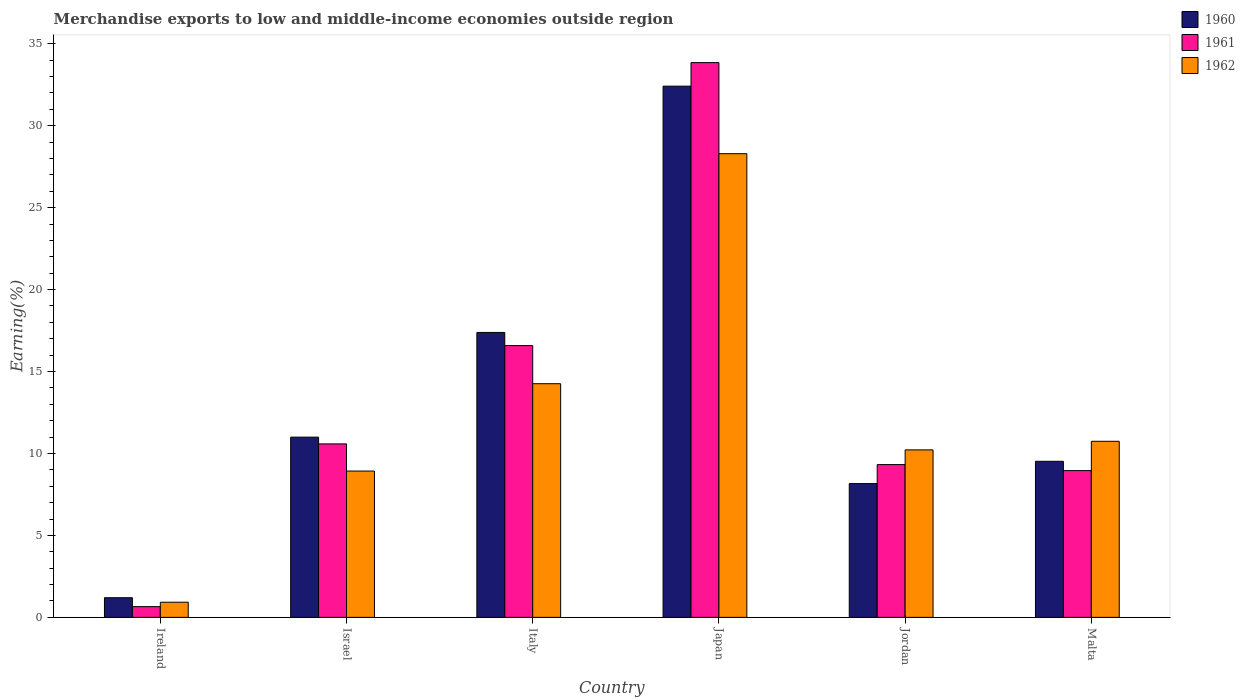Are the number of bars per tick equal to the number of legend labels?
Ensure brevity in your answer.  Yes. How many bars are there on the 6th tick from the right?
Offer a very short reply. 3. What is the label of the 3rd group of bars from the left?
Your answer should be compact. Italy. In how many cases, is the number of bars for a given country not equal to the number of legend labels?
Your answer should be compact. 0. What is the percentage of amount earned from merchandise exports in 1960 in Israel?
Make the answer very short. 11. Across all countries, what is the maximum percentage of amount earned from merchandise exports in 1960?
Offer a terse response. 32.41. Across all countries, what is the minimum percentage of amount earned from merchandise exports in 1962?
Offer a very short reply. 0.92. In which country was the percentage of amount earned from merchandise exports in 1960 maximum?
Keep it short and to the point. Japan. In which country was the percentage of amount earned from merchandise exports in 1962 minimum?
Offer a terse response. Ireland. What is the total percentage of amount earned from merchandise exports in 1962 in the graph?
Offer a very short reply. 73.37. What is the difference between the percentage of amount earned from merchandise exports in 1962 in Italy and that in Jordan?
Ensure brevity in your answer.  4.04. What is the difference between the percentage of amount earned from merchandise exports in 1962 in Israel and the percentage of amount earned from merchandise exports in 1961 in Italy?
Offer a very short reply. -7.66. What is the average percentage of amount earned from merchandise exports in 1961 per country?
Provide a succinct answer. 13.33. What is the difference between the percentage of amount earned from merchandise exports of/in 1961 and percentage of amount earned from merchandise exports of/in 1962 in Jordan?
Make the answer very short. -0.9. In how many countries, is the percentage of amount earned from merchandise exports in 1961 greater than 2 %?
Your response must be concise. 5. What is the ratio of the percentage of amount earned from merchandise exports in 1962 in Ireland to that in Malta?
Ensure brevity in your answer.  0.09. Is the percentage of amount earned from merchandise exports in 1961 in Ireland less than that in Japan?
Your answer should be compact. Yes. Is the difference between the percentage of amount earned from merchandise exports in 1961 in Jordan and Malta greater than the difference between the percentage of amount earned from merchandise exports in 1962 in Jordan and Malta?
Give a very brief answer. Yes. What is the difference between the highest and the second highest percentage of amount earned from merchandise exports in 1961?
Your answer should be very brief. -17.27. What is the difference between the highest and the lowest percentage of amount earned from merchandise exports in 1960?
Ensure brevity in your answer.  31.21. In how many countries, is the percentage of amount earned from merchandise exports in 1961 greater than the average percentage of amount earned from merchandise exports in 1961 taken over all countries?
Ensure brevity in your answer.  2. Is the sum of the percentage of amount earned from merchandise exports in 1961 in Israel and Malta greater than the maximum percentage of amount earned from merchandise exports in 1962 across all countries?
Provide a succinct answer. No. What does the 2nd bar from the left in Israel represents?
Your answer should be compact. 1961. How many countries are there in the graph?
Make the answer very short. 6. What is the difference between two consecutive major ticks on the Y-axis?
Offer a very short reply. 5. What is the title of the graph?
Your answer should be very brief. Merchandise exports to low and middle-income economies outside region. Does "1990" appear as one of the legend labels in the graph?
Offer a very short reply. No. What is the label or title of the Y-axis?
Offer a terse response. Earning(%). What is the Earning(%) of 1960 in Ireland?
Your answer should be very brief. 1.2. What is the Earning(%) of 1961 in Ireland?
Keep it short and to the point. 0.65. What is the Earning(%) of 1962 in Ireland?
Your answer should be very brief. 0.92. What is the Earning(%) in 1960 in Israel?
Make the answer very short. 11. What is the Earning(%) in 1961 in Israel?
Your answer should be compact. 10.58. What is the Earning(%) of 1962 in Israel?
Offer a very short reply. 8.93. What is the Earning(%) of 1960 in Italy?
Provide a short and direct response. 17.38. What is the Earning(%) of 1961 in Italy?
Offer a very short reply. 16.58. What is the Earning(%) in 1962 in Italy?
Ensure brevity in your answer.  14.26. What is the Earning(%) in 1960 in Japan?
Your answer should be compact. 32.41. What is the Earning(%) in 1961 in Japan?
Make the answer very short. 33.85. What is the Earning(%) of 1962 in Japan?
Provide a succinct answer. 28.29. What is the Earning(%) of 1960 in Jordan?
Keep it short and to the point. 8.16. What is the Earning(%) in 1961 in Jordan?
Your answer should be very brief. 9.32. What is the Earning(%) in 1962 in Jordan?
Offer a terse response. 10.22. What is the Earning(%) of 1960 in Malta?
Offer a terse response. 9.52. What is the Earning(%) of 1961 in Malta?
Your response must be concise. 8.96. What is the Earning(%) of 1962 in Malta?
Offer a very short reply. 10.74. Across all countries, what is the maximum Earning(%) of 1960?
Your answer should be very brief. 32.41. Across all countries, what is the maximum Earning(%) in 1961?
Provide a succinct answer. 33.85. Across all countries, what is the maximum Earning(%) in 1962?
Offer a very short reply. 28.29. Across all countries, what is the minimum Earning(%) of 1960?
Your response must be concise. 1.2. Across all countries, what is the minimum Earning(%) in 1961?
Provide a short and direct response. 0.65. Across all countries, what is the minimum Earning(%) in 1962?
Your answer should be compact. 0.92. What is the total Earning(%) of 1960 in the graph?
Provide a short and direct response. 79.68. What is the total Earning(%) in 1961 in the graph?
Provide a succinct answer. 79.95. What is the total Earning(%) of 1962 in the graph?
Give a very brief answer. 73.37. What is the difference between the Earning(%) in 1960 in Ireland and that in Israel?
Offer a very short reply. -9.8. What is the difference between the Earning(%) of 1961 in Ireland and that in Israel?
Provide a short and direct response. -9.93. What is the difference between the Earning(%) in 1962 in Ireland and that in Israel?
Provide a succinct answer. -8. What is the difference between the Earning(%) of 1960 in Ireland and that in Italy?
Your answer should be compact. -16.19. What is the difference between the Earning(%) of 1961 in Ireland and that in Italy?
Your response must be concise. -15.93. What is the difference between the Earning(%) of 1962 in Ireland and that in Italy?
Keep it short and to the point. -13.33. What is the difference between the Earning(%) of 1960 in Ireland and that in Japan?
Offer a very short reply. -31.21. What is the difference between the Earning(%) in 1961 in Ireland and that in Japan?
Your answer should be very brief. -33.2. What is the difference between the Earning(%) in 1962 in Ireland and that in Japan?
Provide a short and direct response. -27.37. What is the difference between the Earning(%) of 1960 in Ireland and that in Jordan?
Provide a short and direct response. -6.96. What is the difference between the Earning(%) in 1961 in Ireland and that in Jordan?
Provide a short and direct response. -8.67. What is the difference between the Earning(%) of 1962 in Ireland and that in Jordan?
Offer a terse response. -9.29. What is the difference between the Earning(%) of 1960 in Ireland and that in Malta?
Give a very brief answer. -8.32. What is the difference between the Earning(%) of 1961 in Ireland and that in Malta?
Offer a very short reply. -8.3. What is the difference between the Earning(%) of 1962 in Ireland and that in Malta?
Keep it short and to the point. -9.82. What is the difference between the Earning(%) of 1960 in Israel and that in Italy?
Provide a succinct answer. -6.39. What is the difference between the Earning(%) in 1961 in Israel and that in Italy?
Keep it short and to the point. -6. What is the difference between the Earning(%) of 1962 in Israel and that in Italy?
Offer a very short reply. -5.33. What is the difference between the Earning(%) of 1960 in Israel and that in Japan?
Provide a succinct answer. -21.42. What is the difference between the Earning(%) in 1961 in Israel and that in Japan?
Give a very brief answer. -23.27. What is the difference between the Earning(%) in 1962 in Israel and that in Japan?
Make the answer very short. -19.37. What is the difference between the Earning(%) of 1960 in Israel and that in Jordan?
Your answer should be compact. 2.83. What is the difference between the Earning(%) of 1961 in Israel and that in Jordan?
Offer a terse response. 1.26. What is the difference between the Earning(%) of 1962 in Israel and that in Jordan?
Give a very brief answer. -1.29. What is the difference between the Earning(%) in 1960 in Israel and that in Malta?
Offer a terse response. 1.47. What is the difference between the Earning(%) of 1961 in Israel and that in Malta?
Your answer should be compact. 1.63. What is the difference between the Earning(%) in 1962 in Israel and that in Malta?
Offer a very short reply. -1.82. What is the difference between the Earning(%) of 1960 in Italy and that in Japan?
Your response must be concise. -15.03. What is the difference between the Earning(%) in 1961 in Italy and that in Japan?
Your answer should be compact. -17.27. What is the difference between the Earning(%) in 1962 in Italy and that in Japan?
Your answer should be compact. -14.04. What is the difference between the Earning(%) of 1960 in Italy and that in Jordan?
Keep it short and to the point. 9.22. What is the difference between the Earning(%) in 1961 in Italy and that in Jordan?
Provide a succinct answer. 7.26. What is the difference between the Earning(%) of 1962 in Italy and that in Jordan?
Offer a terse response. 4.04. What is the difference between the Earning(%) of 1960 in Italy and that in Malta?
Your response must be concise. 7.86. What is the difference between the Earning(%) in 1961 in Italy and that in Malta?
Ensure brevity in your answer.  7.63. What is the difference between the Earning(%) in 1962 in Italy and that in Malta?
Make the answer very short. 3.51. What is the difference between the Earning(%) in 1960 in Japan and that in Jordan?
Provide a succinct answer. 24.25. What is the difference between the Earning(%) of 1961 in Japan and that in Jordan?
Give a very brief answer. 24.53. What is the difference between the Earning(%) in 1962 in Japan and that in Jordan?
Keep it short and to the point. 18.07. What is the difference between the Earning(%) in 1960 in Japan and that in Malta?
Provide a succinct answer. 22.89. What is the difference between the Earning(%) of 1961 in Japan and that in Malta?
Your answer should be very brief. 24.9. What is the difference between the Earning(%) of 1962 in Japan and that in Malta?
Your response must be concise. 17.55. What is the difference between the Earning(%) of 1960 in Jordan and that in Malta?
Your response must be concise. -1.36. What is the difference between the Earning(%) in 1961 in Jordan and that in Malta?
Offer a very short reply. 0.37. What is the difference between the Earning(%) of 1962 in Jordan and that in Malta?
Provide a succinct answer. -0.52. What is the difference between the Earning(%) in 1960 in Ireland and the Earning(%) in 1961 in Israel?
Make the answer very short. -9.39. What is the difference between the Earning(%) of 1960 in Ireland and the Earning(%) of 1962 in Israel?
Your answer should be compact. -7.73. What is the difference between the Earning(%) of 1961 in Ireland and the Earning(%) of 1962 in Israel?
Offer a very short reply. -8.27. What is the difference between the Earning(%) of 1960 in Ireland and the Earning(%) of 1961 in Italy?
Offer a very short reply. -15.38. What is the difference between the Earning(%) in 1960 in Ireland and the Earning(%) in 1962 in Italy?
Ensure brevity in your answer.  -13.06. What is the difference between the Earning(%) in 1961 in Ireland and the Earning(%) in 1962 in Italy?
Offer a terse response. -13.6. What is the difference between the Earning(%) in 1960 in Ireland and the Earning(%) in 1961 in Japan?
Provide a succinct answer. -32.65. What is the difference between the Earning(%) of 1960 in Ireland and the Earning(%) of 1962 in Japan?
Offer a terse response. -27.09. What is the difference between the Earning(%) in 1961 in Ireland and the Earning(%) in 1962 in Japan?
Provide a short and direct response. -27.64. What is the difference between the Earning(%) of 1960 in Ireland and the Earning(%) of 1961 in Jordan?
Offer a very short reply. -8.12. What is the difference between the Earning(%) of 1960 in Ireland and the Earning(%) of 1962 in Jordan?
Offer a very short reply. -9.02. What is the difference between the Earning(%) of 1961 in Ireland and the Earning(%) of 1962 in Jordan?
Keep it short and to the point. -9.56. What is the difference between the Earning(%) in 1960 in Ireland and the Earning(%) in 1961 in Malta?
Make the answer very short. -7.76. What is the difference between the Earning(%) of 1960 in Ireland and the Earning(%) of 1962 in Malta?
Offer a very short reply. -9.54. What is the difference between the Earning(%) of 1961 in Ireland and the Earning(%) of 1962 in Malta?
Offer a terse response. -10.09. What is the difference between the Earning(%) of 1960 in Israel and the Earning(%) of 1961 in Italy?
Your response must be concise. -5.59. What is the difference between the Earning(%) of 1960 in Israel and the Earning(%) of 1962 in Italy?
Give a very brief answer. -3.26. What is the difference between the Earning(%) of 1961 in Israel and the Earning(%) of 1962 in Italy?
Offer a terse response. -3.67. What is the difference between the Earning(%) of 1960 in Israel and the Earning(%) of 1961 in Japan?
Provide a short and direct response. -22.85. What is the difference between the Earning(%) in 1960 in Israel and the Earning(%) in 1962 in Japan?
Give a very brief answer. -17.3. What is the difference between the Earning(%) in 1961 in Israel and the Earning(%) in 1962 in Japan?
Offer a terse response. -17.71. What is the difference between the Earning(%) of 1960 in Israel and the Earning(%) of 1961 in Jordan?
Provide a succinct answer. 1.68. What is the difference between the Earning(%) of 1960 in Israel and the Earning(%) of 1962 in Jordan?
Keep it short and to the point. 0.78. What is the difference between the Earning(%) in 1961 in Israel and the Earning(%) in 1962 in Jordan?
Your answer should be compact. 0.37. What is the difference between the Earning(%) of 1960 in Israel and the Earning(%) of 1961 in Malta?
Offer a terse response. 2.04. What is the difference between the Earning(%) in 1960 in Israel and the Earning(%) in 1962 in Malta?
Offer a terse response. 0.25. What is the difference between the Earning(%) in 1961 in Israel and the Earning(%) in 1962 in Malta?
Keep it short and to the point. -0.16. What is the difference between the Earning(%) in 1960 in Italy and the Earning(%) in 1961 in Japan?
Your response must be concise. -16.47. What is the difference between the Earning(%) of 1960 in Italy and the Earning(%) of 1962 in Japan?
Your answer should be compact. -10.91. What is the difference between the Earning(%) of 1961 in Italy and the Earning(%) of 1962 in Japan?
Give a very brief answer. -11.71. What is the difference between the Earning(%) in 1960 in Italy and the Earning(%) in 1961 in Jordan?
Make the answer very short. 8.06. What is the difference between the Earning(%) of 1960 in Italy and the Earning(%) of 1962 in Jordan?
Provide a short and direct response. 7.17. What is the difference between the Earning(%) of 1961 in Italy and the Earning(%) of 1962 in Jordan?
Offer a very short reply. 6.36. What is the difference between the Earning(%) of 1960 in Italy and the Earning(%) of 1961 in Malta?
Provide a succinct answer. 8.43. What is the difference between the Earning(%) in 1960 in Italy and the Earning(%) in 1962 in Malta?
Give a very brief answer. 6.64. What is the difference between the Earning(%) of 1961 in Italy and the Earning(%) of 1962 in Malta?
Your answer should be very brief. 5.84. What is the difference between the Earning(%) in 1960 in Japan and the Earning(%) in 1961 in Jordan?
Give a very brief answer. 23.09. What is the difference between the Earning(%) in 1960 in Japan and the Earning(%) in 1962 in Jordan?
Provide a succinct answer. 22.2. What is the difference between the Earning(%) of 1961 in Japan and the Earning(%) of 1962 in Jordan?
Keep it short and to the point. 23.63. What is the difference between the Earning(%) of 1960 in Japan and the Earning(%) of 1961 in Malta?
Ensure brevity in your answer.  23.46. What is the difference between the Earning(%) of 1960 in Japan and the Earning(%) of 1962 in Malta?
Ensure brevity in your answer.  21.67. What is the difference between the Earning(%) of 1961 in Japan and the Earning(%) of 1962 in Malta?
Your response must be concise. 23.11. What is the difference between the Earning(%) in 1960 in Jordan and the Earning(%) in 1961 in Malta?
Make the answer very short. -0.79. What is the difference between the Earning(%) of 1960 in Jordan and the Earning(%) of 1962 in Malta?
Ensure brevity in your answer.  -2.58. What is the difference between the Earning(%) of 1961 in Jordan and the Earning(%) of 1962 in Malta?
Offer a terse response. -1.42. What is the average Earning(%) of 1960 per country?
Provide a succinct answer. 13.28. What is the average Earning(%) of 1961 per country?
Your answer should be very brief. 13.33. What is the average Earning(%) in 1962 per country?
Make the answer very short. 12.23. What is the difference between the Earning(%) in 1960 and Earning(%) in 1961 in Ireland?
Your response must be concise. 0.54. What is the difference between the Earning(%) in 1960 and Earning(%) in 1962 in Ireland?
Keep it short and to the point. 0.27. What is the difference between the Earning(%) of 1961 and Earning(%) of 1962 in Ireland?
Your answer should be compact. -0.27. What is the difference between the Earning(%) of 1960 and Earning(%) of 1961 in Israel?
Keep it short and to the point. 0.41. What is the difference between the Earning(%) in 1960 and Earning(%) in 1962 in Israel?
Make the answer very short. 2.07. What is the difference between the Earning(%) in 1961 and Earning(%) in 1962 in Israel?
Give a very brief answer. 1.66. What is the difference between the Earning(%) in 1960 and Earning(%) in 1961 in Italy?
Ensure brevity in your answer.  0.8. What is the difference between the Earning(%) of 1960 and Earning(%) of 1962 in Italy?
Ensure brevity in your answer.  3.13. What is the difference between the Earning(%) in 1961 and Earning(%) in 1962 in Italy?
Your answer should be compact. 2.33. What is the difference between the Earning(%) in 1960 and Earning(%) in 1961 in Japan?
Your answer should be compact. -1.44. What is the difference between the Earning(%) of 1960 and Earning(%) of 1962 in Japan?
Provide a succinct answer. 4.12. What is the difference between the Earning(%) of 1961 and Earning(%) of 1962 in Japan?
Offer a very short reply. 5.56. What is the difference between the Earning(%) of 1960 and Earning(%) of 1961 in Jordan?
Offer a terse response. -1.16. What is the difference between the Earning(%) of 1960 and Earning(%) of 1962 in Jordan?
Your answer should be compact. -2.06. What is the difference between the Earning(%) in 1961 and Earning(%) in 1962 in Jordan?
Provide a succinct answer. -0.9. What is the difference between the Earning(%) of 1960 and Earning(%) of 1961 in Malta?
Provide a succinct answer. 0.57. What is the difference between the Earning(%) in 1960 and Earning(%) in 1962 in Malta?
Your answer should be compact. -1.22. What is the difference between the Earning(%) of 1961 and Earning(%) of 1962 in Malta?
Provide a succinct answer. -1.79. What is the ratio of the Earning(%) in 1960 in Ireland to that in Israel?
Ensure brevity in your answer.  0.11. What is the ratio of the Earning(%) of 1961 in Ireland to that in Israel?
Ensure brevity in your answer.  0.06. What is the ratio of the Earning(%) in 1962 in Ireland to that in Israel?
Provide a short and direct response. 0.1. What is the ratio of the Earning(%) of 1960 in Ireland to that in Italy?
Provide a short and direct response. 0.07. What is the ratio of the Earning(%) of 1961 in Ireland to that in Italy?
Ensure brevity in your answer.  0.04. What is the ratio of the Earning(%) in 1962 in Ireland to that in Italy?
Offer a terse response. 0.06. What is the ratio of the Earning(%) in 1960 in Ireland to that in Japan?
Keep it short and to the point. 0.04. What is the ratio of the Earning(%) of 1961 in Ireland to that in Japan?
Provide a succinct answer. 0.02. What is the ratio of the Earning(%) in 1962 in Ireland to that in Japan?
Your response must be concise. 0.03. What is the ratio of the Earning(%) in 1960 in Ireland to that in Jordan?
Your response must be concise. 0.15. What is the ratio of the Earning(%) in 1961 in Ireland to that in Jordan?
Offer a terse response. 0.07. What is the ratio of the Earning(%) in 1962 in Ireland to that in Jordan?
Make the answer very short. 0.09. What is the ratio of the Earning(%) in 1960 in Ireland to that in Malta?
Your answer should be very brief. 0.13. What is the ratio of the Earning(%) of 1961 in Ireland to that in Malta?
Your answer should be compact. 0.07. What is the ratio of the Earning(%) in 1962 in Ireland to that in Malta?
Provide a short and direct response. 0.09. What is the ratio of the Earning(%) of 1960 in Israel to that in Italy?
Keep it short and to the point. 0.63. What is the ratio of the Earning(%) of 1961 in Israel to that in Italy?
Make the answer very short. 0.64. What is the ratio of the Earning(%) in 1962 in Israel to that in Italy?
Your answer should be compact. 0.63. What is the ratio of the Earning(%) in 1960 in Israel to that in Japan?
Your response must be concise. 0.34. What is the ratio of the Earning(%) of 1961 in Israel to that in Japan?
Offer a very short reply. 0.31. What is the ratio of the Earning(%) of 1962 in Israel to that in Japan?
Your answer should be very brief. 0.32. What is the ratio of the Earning(%) in 1960 in Israel to that in Jordan?
Keep it short and to the point. 1.35. What is the ratio of the Earning(%) of 1961 in Israel to that in Jordan?
Keep it short and to the point. 1.14. What is the ratio of the Earning(%) in 1962 in Israel to that in Jordan?
Your response must be concise. 0.87. What is the ratio of the Earning(%) of 1960 in Israel to that in Malta?
Make the answer very short. 1.15. What is the ratio of the Earning(%) in 1961 in Israel to that in Malta?
Your response must be concise. 1.18. What is the ratio of the Earning(%) of 1962 in Israel to that in Malta?
Offer a terse response. 0.83. What is the ratio of the Earning(%) in 1960 in Italy to that in Japan?
Offer a terse response. 0.54. What is the ratio of the Earning(%) in 1961 in Italy to that in Japan?
Provide a short and direct response. 0.49. What is the ratio of the Earning(%) of 1962 in Italy to that in Japan?
Keep it short and to the point. 0.5. What is the ratio of the Earning(%) in 1960 in Italy to that in Jordan?
Your answer should be compact. 2.13. What is the ratio of the Earning(%) in 1961 in Italy to that in Jordan?
Your response must be concise. 1.78. What is the ratio of the Earning(%) in 1962 in Italy to that in Jordan?
Give a very brief answer. 1.4. What is the ratio of the Earning(%) of 1960 in Italy to that in Malta?
Provide a short and direct response. 1.83. What is the ratio of the Earning(%) in 1961 in Italy to that in Malta?
Provide a short and direct response. 1.85. What is the ratio of the Earning(%) in 1962 in Italy to that in Malta?
Keep it short and to the point. 1.33. What is the ratio of the Earning(%) in 1960 in Japan to that in Jordan?
Offer a terse response. 3.97. What is the ratio of the Earning(%) of 1961 in Japan to that in Jordan?
Your answer should be very brief. 3.63. What is the ratio of the Earning(%) of 1962 in Japan to that in Jordan?
Give a very brief answer. 2.77. What is the ratio of the Earning(%) of 1960 in Japan to that in Malta?
Your answer should be very brief. 3.4. What is the ratio of the Earning(%) of 1961 in Japan to that in Malta?
Ensure brevity in your answer.  3.78. What is the ratio of the Earning(%) in 1962 in Japan to that in Malta?
Give a very brief answer. 2.63. What is the ratio of the Earning(%) in 1960 in Jordan to that in Malta?
Make the answer very short. 0.86. What is the ratio of the Earning(%) of 1961 in Jordan to that in Malta?
Keep it short and to the point. 1.04. What is the ratio of the Earning(%) of 1962 in Jordan to that in Malta?
Your answer should be compact. 0.95. What is the difference between the highest and the second highest Earning(%) of 1960?
Keep it short and to the point. 15.03. What is the difference between the highest and the second highest Earning(%) of 1961?
Ensure brevity in your answer.  17.27. What is the difference between the highest and the second highest Earning(%) of 1962?
Offer a terse response. 14.04. What is the difference between the highest and the lowest Earning(%) in 1960?
Keep it short and to the point. 31.21. What is the difference between the highest and the lowest Earning(%) in 1961?
Ensure brevity in your answer.  33.2. What is the difference between the highest and the lowest Earning(%) of 1962?
Make the answer very short. 27.37. 